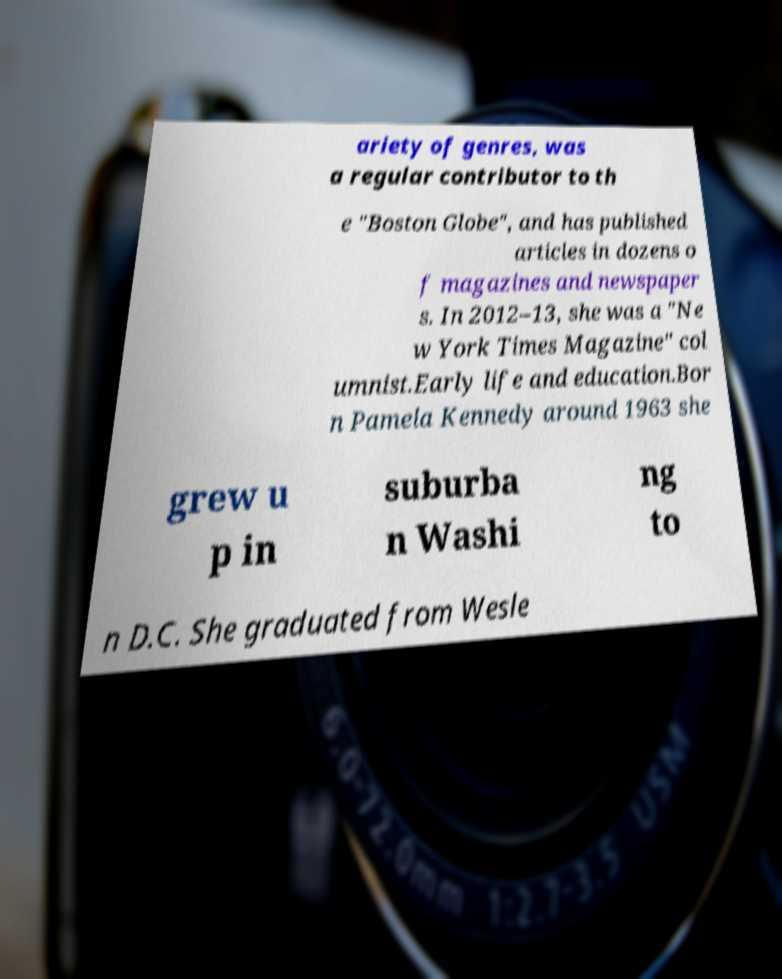Can you read and provide the text displayed in the image?This photo seems to have some interesting text. Can you extract and type it out for me? ariety of genres, was a regular contributor to th e "Boston Globe", and has published articles in dozens o f magazines and newspaper s. In 2012–13, she was a "Ne w York Times Magazine" col umnist.Early life and education.Bor n Pamela Kennedy around 1963 she grew u p in suburba n Washi ng to n D.C. She graduated from Wesle 